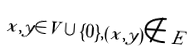Convert formula to latex. <formula><loc_0><loc_0><loc_500><loc_500>x , y \in V \cup \{ 0 \} , ( x , y ) \notin E</formula> 